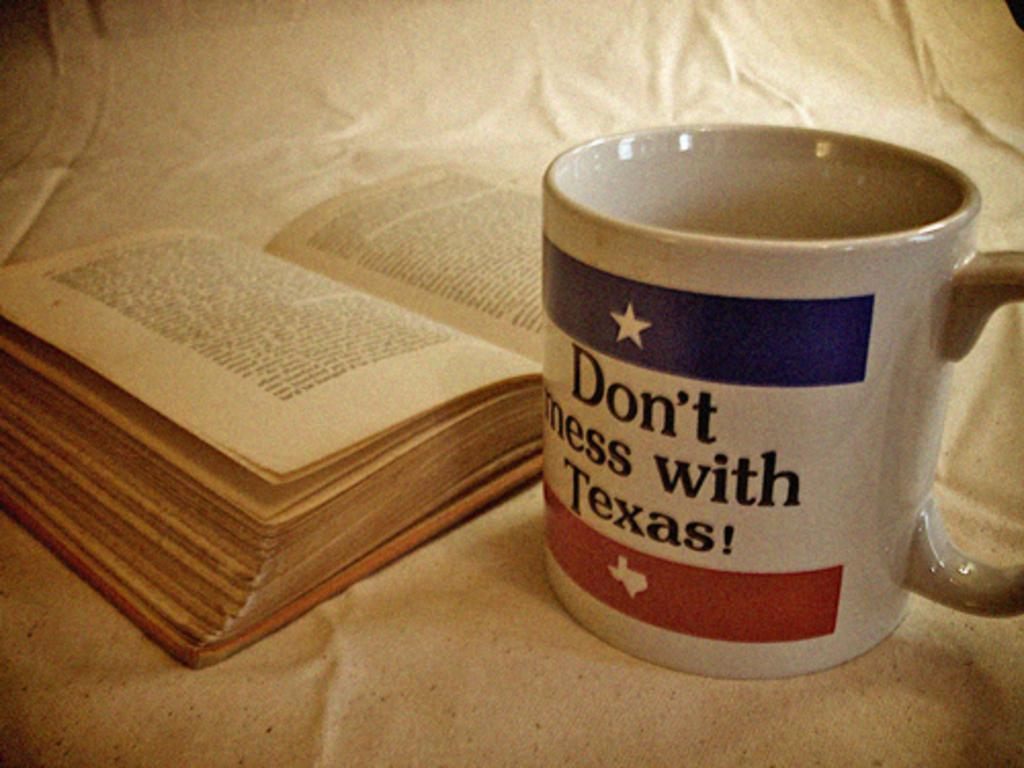<image>
Provide a brief description of the given image. A book next to a mug saying Don't mess with Texas 